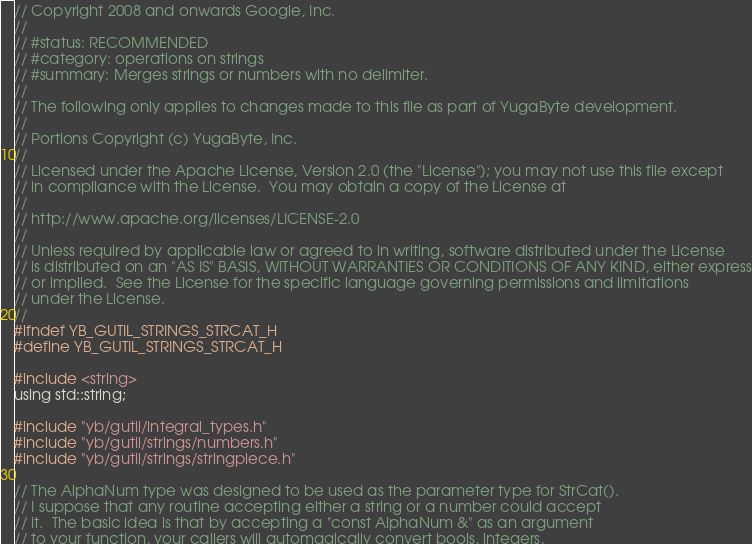Convert code to text. <code><loc_0><loc_0><loc_500><loc_500><_C_>// Copyright 2008 and onwards Google, Inc.
//
// #status: RECOMMENDED
// #category: operations on strings
// #summary: Merges strings or numbers with no delimiter.
//
// The following only applies to changes made to this file as part of YugaByte development.
//
// Portions Copyright (c) YugaByte, Inc.
//
// Licensed under the Apache License, Version 2.0 (the "License"); you may not use this file except
// in compliance with the License.  You may obtain a copy of the License at
//
// http://www.apache.org/licenses/LICENSE-2.0
//
// Unless required by applicable law or agreed to in writing, software distributed under the License
// is distributed on an "AS IS" BASIS, WITHOUT WARRANTIES OR CONDITIONS OF ANY KIND, either express
// or implied.  See the License for the specific language governing permissions and limitations
// under the License.
//
#ifndef YB_GUTIL_STRINGS_STRCAT_H
#define YB_GUTIL_STRINGS_STRCAT_H

#include <string>
using std::string;

#include "yb/gutil/integral_types.h"
#include "yb/gutil/strings/numbers.h"
#include "yb/gutil/strings/stringpiece.h"

// The AlphaNum type was designed to be used as the parameter type for StrCat().
// I suppose that any routine accepting either a string or a number could accept
// it.  The basic idea is that by accepting a "const AlphaNum &" as an argument
// to your function, your callers will automagically convert bools, integers,</code> 